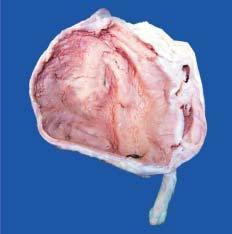does the incised wound as well as suture track on either side show markedly dilated pelvis and calyces having irregular and ragged inner surface and containing necrotic debris and pus?
Answer the question using a single word or phrase. No 